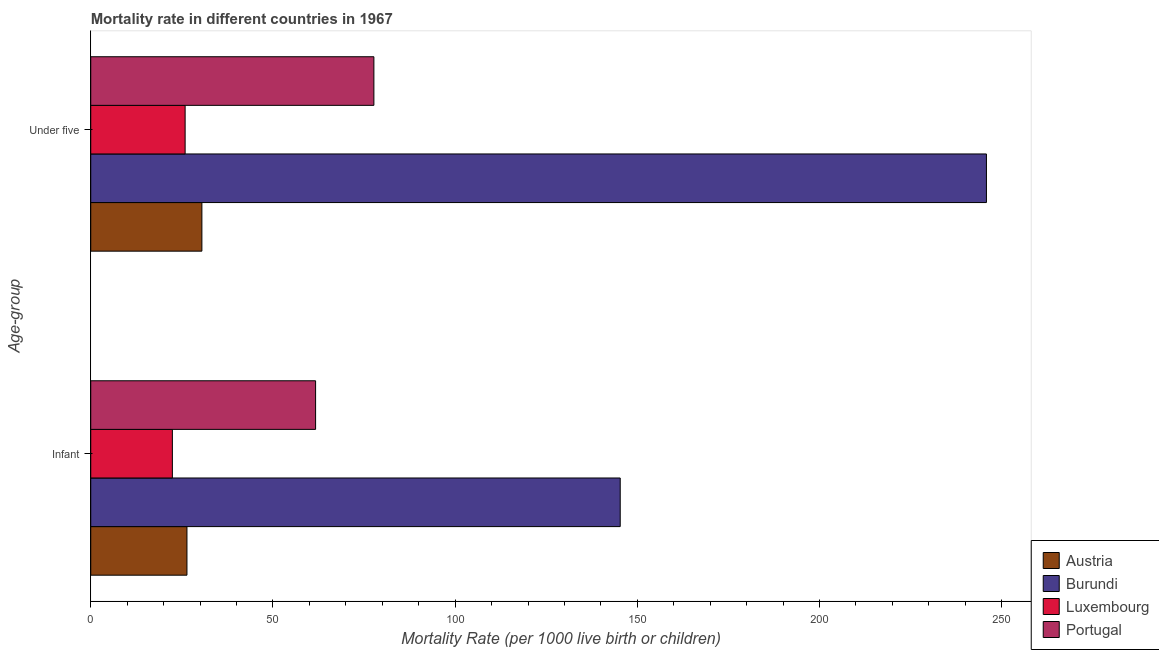How many different coloured bars are there?
Offer a terse response. 4. How many bars are there on the 1st tick from the top?
Offer a terse response. 4. How many bars are there on the 1st tick from the bottom?
Give a very brief answer. 4. What is the label of the 2nd group of bars from the top?
Offer a terse response. Infant. What is the under-5 mortality rate in Burundi?
Your answer should be very brief. 245.8. Across all countries, what is the maximum infant mortality rate?
Provide a succinct answer. 145.3. Across all countries, what is the minimum infant mortality rate?
Give a very brief answer. 22.4. In which country was the infant mortality rate maximum?
Keep it short and to the point. Burundi. In which country was the infant mortality rate minimum?
Ensure brevity in your answer.  Luxembourg. What is the total under-5 mortality rate in the graph?
Offer a very short reply. 379.9. What is the difference between the under-5 mortality rate in Burundi and the infant mortality rate in Luxembourg?
Give a very brief answer. 223.4. What is the average infant mortality rate per country?
Keep it short and to the point. 63.95. What is the difference between the under-5 mortality rate and infant mortality rate in Austria?
Give a very brief answer. 4.1. In how many countries, is the infant mortality rate greater than 140 ?
Keep it short and to the point. 1. What is the ratio of the under-5 mortality rate in Austria to that in Portugal?
Keep it short and to the point. 0.39. Is the infant mortality rate in Burundi less than that in Luxembourg?
Offer a very short reply. No. What does the 2nd bar from the top in Infant represents?
Keep it short and to the point. Luxembourg. How many bars are there?
Your answer should be compact. 8. How many countries are there in the graph?
Give a very brief answer. 4. Are the values on the major ticks of X-axis written in scientific E-notation?
Your answer should be compact. No. Does the graph contain grids?
Give a very brief answer. No. Where does the legend appear in the graph?
Provide a succinct answer. Bottom right. How are the legend labels stacked?
Provide a short and direct response. Vertical. What is the title of the graph?
Make the answer very short. Mortality rate in different countries in 1967. What is the label or title of the X-axis?
Your answer should be very brief. Mortality Rate (per 1000 live birth or children). What is the label or title of the Y-axis?
Your response must be concise. Age-group. What is the Mortality Rate (per 1000 live birth or children) of Austria in Infant?
Your answer should be compact. 26.4. What is the Mortality Rate (per 1000 live birth or children) of Burundi in Infant?
Your answer should be compact. 145.3. What is the Mortality Rate (per 1000 live birth or children) in Luxembourg in Infant?
Give a very brief answer. 22.4. What is the Mortality Rate (per 1000 live birth or children) in Portugal in Infant?
Provide a short and direct response. 61.7. What is the Mortality Rate (per 1000 live birth or children) of Austria in Under five?
Keep it short and to the point. 30.5. What is the Mortality Rate (per 1000 live birth or children) in Burundi in Under five?
Make the answer very short. 245.8. What is the Mortality Rate (per 1000 live birth or children) of Luxembourg in Under five?
Provide a short and direct response. 25.9. What is the Mortality Rate (per 1000 live birth or children) in Portugal in Under five?
Your answer should be compact. 77.7. Across all Age-group, what is the maximum Mortality Rate (per 1000 live birth or children) in Austria?
Provide a short and direct response. 30.5. Across all Age-group, what is the maximum Mortality Rate (per 1000 live birth or children) in Burundi?
Give a very brief answer. 245.8. Across all Age-group, what is the maximum Mortality Rate (per 1000 live birth or children) in Luxembourg?
Your answer should be very brief. 25.9. Across all Age-group, what is the maximum Mortality Rate (per 1000 live birth or children) of Portugal?
Keep it short and to the point. 77.7. Across all Age-group, what is the minimum Mortality Rate (per 1000 live birth or children) in Austria?
Your answer should be compact. 26.4. Across all Age-group, what is the minimum Mortality Rate (per 1000 live birth or children) of Burundi?
Provide a short and direct response. 145.3. Across all Age-group, what is the minimum Mortality Rate (per 1000 live birth or children) of Luxembourg?
Provide a short and direct response. 22.4. Across all Age-group, what is the minimum Mortality Rate (per 1000 live birth or children) of Portugal?
Your answer should be very brief. 61.7. What is the total Mortality Rate (per 1000 live birth or children) in Austria in the graph?
Your answer should be compact. 56.9. What is the total Mortality Rate (per 1000 live birth or children) of Burundi in the graph?
Offer a very short reply. 391.1. What is the total Mortality Rate (per 1000 live birth or children) in Luxembourg in the graph?
Your answer should be compact. 48.3. What is the total Mortality Rate (per 1000 live birth or children) in Portugal in the graph?
Offer a very short reply. 139.4. What is the difference between the Mortality Rate (per 1000 live birth or children) of Austria in Infant and that in Under five?
Make the answer very short. -4.1. What is the difference between the Mortality Rate (per 1000 live birth or children) in Burundi in Infant and that in Under five?
Your answer should be compact. -100.5. What is the difference between the Mortality Rate (per 1000 live birth or children) in Luxembourg in Infant and that in Under five?
Ensure brevity in your answer.  -3.5. What is the difference between the Mortality Rate (per 1000 live birth or children) of Portugal in Infant and that in Under five?
Provide a short and direct response. -16. What is the difference between the Mortality Rate (per 1000 live birth or children) of Austria in Infant and the Mortality Rate (per 1000 live birth or children) of Burundi in Under five?
Make the answer very short. -219.4. What is the difference between the Mortality Rate (per 1000 live birth or children) of Austria in Infant and the Mortality Rate (per 1000 live birth or children) of Portugal in Under five?
Provide a succinct answer. -51.3. What is the difference between the Mortality Rate (per 1000 live birth or children) in Burundi in Infant and the Mortality Rate (per 1000 live birth or children) in Luxembourg in Under five?
Offer a very short reply. 119.4. What is the difference between the Mortality Rate (per 1000 live birth or children) of Burundi in Infant and the Mortality Rate (per 1000 live birth or children) of Portugal in Under five?
Keep it short and to the point. 67.6. What is the difference between the Mortality Rate (per 1000 live birth or children) in Luxembourg in Infant and the Mortality Rate (per 1000 live birth or children) in Portugal in Under five?
Provide a short and direct response. -55.3. What is the average Mortality Rate (per 1000 live birth or children) in Austria per Age-group?
Make the answer very short. 28.45. What is the average Mortality Rate (per 1000 live birth or children) of Burundi per Age-group?
Provide a succinct answer. 195.55. What is the average Mortality Rate (per 1000 live birth or children) of Luxembourg per Age-group?
Your answer should be compact. 24.15. What is the average Mortality Rate (per 1000 live birth or children) in Portugal per Age-group?
Your answer should be compact. 69.7. What is the difference between the Mortality Rate (per 1000 live birth or children) in Austria and Mortality Rate (per 1000 live birth or children) in Burundi in Infant?
Provide a succinct answer. -118.9. What is the difference between the Mortality Rate (per 1000 live birth or children) in Austria and Mortality Rate (per 1000 live birth or children) in Luxembourg in Infant?
Give a very brief answer. 4. What is the difference between the Mortality Rate (per 1000 live birth or children) in Austria and Mortality Rate (per 1000 live birth or children) in Portugal in Infant?
Your answer should be very brief. -35.3. What is the difference between the Mortality Rate (per 1000 live birth or children) in Burundi and Mortality Rate (per 1000 live birth or children) in Luxembourg in Infant?
Ensure brevity in your answer.  122.9. What is the difference between the Mortality Rate (per 1000 live birth or children) in Burundi and Mortality Rate (per 1000 live birth or children) in Portugal in Infant?
Your answer should be compact. 83.6. What is the difference between the Mortality Rate (per 1000 live birth or children) of Luxembourg and Mortality Rate (per 1000 live birth or children) of Portugal in Infant?
Your response must be concise. -39.3. What is the difference between the Mortality Rate (per 1000 live birth or children) of Austria and Mortality Rate (per 1000 live birth or children) of Burundi in Under five?
Keep it short and to the point. -215.3. What is the difference between the Mortality Rate (per 1000 live birth or children) in Austria and Mortality Rate (per 1000 live birth or children) in Luxembourg in Under five?
Offer a terse response. 4.6. What is the difference between the Mortality Rate (per 1000 live birth or children) in Austria and Mortality Rate (per 1000 live birth or children) in Portugal in Under five?
Your response must be concise. -47.2. What is the difference between the Mortality Rate (per 1000 live birth or children) in Burundi and Mortality Rate (per 1000 live birth or children) in Luxembourg in Under five?
Your answer should be very brief. 219.9. What is the difference between the Mortality Rate (per 1000 live birth or children) of Burundi and Mortality Rate (per 1000 live birth or children) of Portugal in Under five?
Your answer should be compact. 168.1. What is the difference between the Mortality Rate (per 1000 live birth or children) of Luxembourg and Mortality Rate (per 1000 live birth or children) of Portugal in Under five?
Make the answer very short. -51.8. What is the ratio of the Mortality Rate (per 1000 live birth or children) in Austria in Infant to that in Under five?
Your response must be concise. 0.87. What is the ratio of the Mortality Rate (per 1000 live birth or children) in Burundi in Infant to that in Under five?
Make the answer very short. 0.59. What is the ratio of the Mortality Rate (per 1000 live birth or children) of Luxembourg in Infant to that in Under five?
Provide a short and direct response. 0.86. What is the ratio of the Mortality Rate (per 1000 live birth or children) of Portugal in Infant to that in Under five?
Give a very brief answer. 0.79. What is the difference between the highest and the second highest Mortality Rate (per 1000 live birth or children) in Austria?
Provide a short and direct response. 4.1. What is the difference between the highest and the second highest Mortality Rate (per 1000 live birth or children) of Burundi?
Keep it short and to the point. 100.5. What is the difference between the highest and the second highest Mortality Rate (per 1000 live birth or children) in Portugal?
Ensure brevity in your answer.  16. What is the difference between the highest and the lowest Mortality Rate (per 1000 live birth or children) in Austria?
Offer a terse response. 4.1. What is the difference between the highest and the lowest Mortality Rate (per 1000 live birth or children) in Burundi?
Ensure brevity in your answer.  100.5. What is the difference between the highest and the lowest Mortality Rate (per 1000 live birth or children) in Luxembourg?
Make the answer very short. 3.5. 